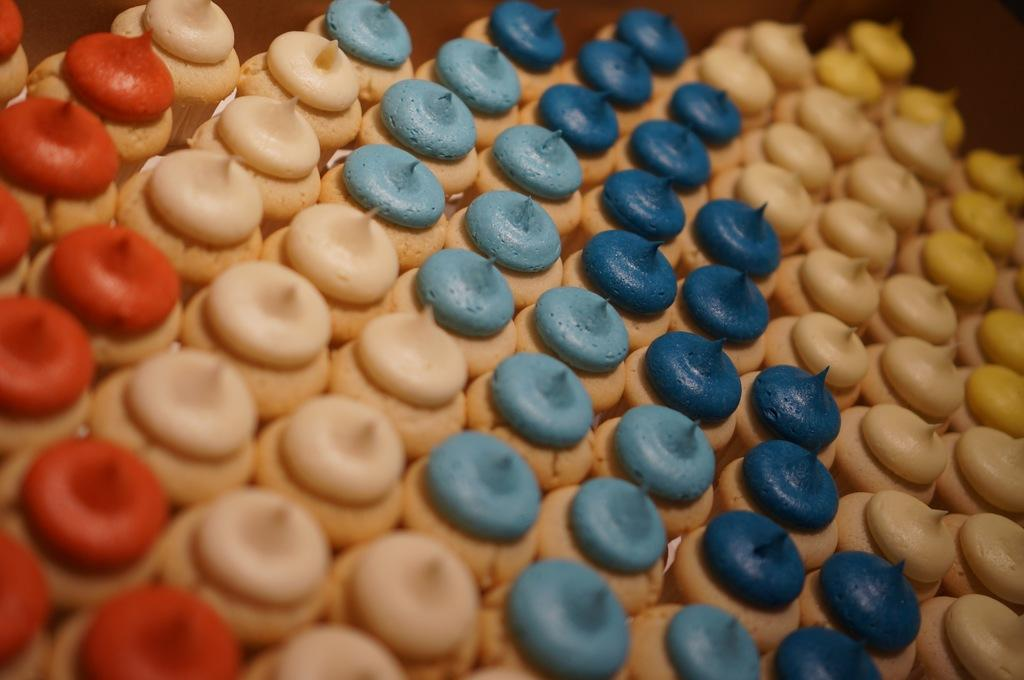What type of food is present in the image? There are cupcakes in the image. Can you describe the appearance of the cupcakes? The cupcakes have different colored cream on them. Who is the expert in the image? There is no expert present in the image; it features cupcakes with different colored cream. 